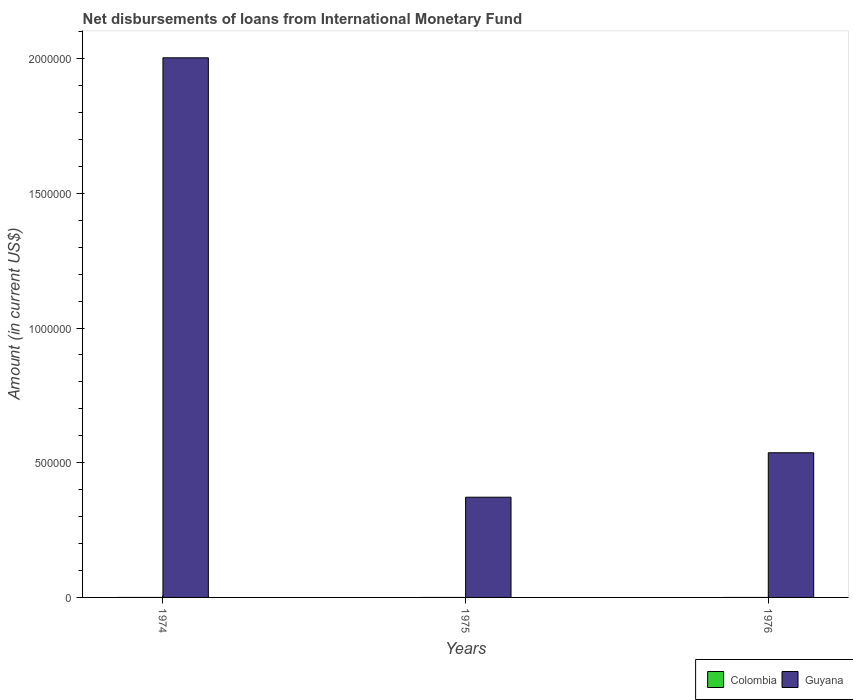How many different coloured bars are there?
Give a very brief answer. 1. How many bars are there on the 1st tick from the left?
Offer a very short reply. 1. What is the label of the 1st group of bars from the left?
Your answer should be very brief. 1974. What is the amount of loans disbursed in Guyana in 1976?
Make the answer very short. 5.37e+05. Across all years, what is the maximum amount of loans disbursed in Guyana?
Offer a terse response. 2.00e+06. Across all years, what is the minimum amount of loans disbursed in Guyana?
Your answer should be compact. 3.72e+05. What is the total amount of loans disbursed in Guyana in the graph?
Your response must be concise. 2.91e+06. What is the difference between the amount of loans disbursed in Guyana in 1974 and that in 1976?
Your response must be concise. 1.47e+06. What is the difference between the amount of loans disbursed in Colombia in 1975 and the amount of loans disbursed in Guyana in 1976?
Offer a very short reply. -5.37e+05. What is the average amount of loans disbursed in Colombia per year?
Provide a succinct answer. 0. In how many years, is the amount of loans disbursed in Guyana greater than 1900000 US$?
Provide a succinct answer. 1. What is the ratio of the amount of loans disbursed in Guyana in 1975 to that in 1976?
Ensure brevity in your answer.  0.69. What is the difference between the highest and the second highest amount of loans disbursed in Guyana?
Offer a very short reply. 1.47e+06. What is the difference between the highest and the lowest amount of loans disbursed in Guyana?
Make the answer very short. 1.63e+06. In how many years, is the amount of loans disbursed in Colombia greater than the average amount of loans disbursed in Colombia taken over all years?
Provide a short and direct response. 0. Is the sum of the amount of loans disbursed in Guyana in 1974 and 1976 greater than the maximum amount of loans disbursed in Colombia across all years?
Offer a very short reply. Yes. How many years are there in the graph?
Give a very brief answer. 3. What is the difference between two consecutive major ticks on the Y-axis?
Your answer should be compact. 5.00e+05. Where does the legend appear in the graph?
Offer a very short reply. Bottom right. How many legend labels are there?
Make the answer very short. 2. What is the title of the graph?
Keep it short and to the point. Net disbursements of loans from International Monetary Fund. What is the label or title of the Y-axis?
Keep it short and to the point. Amount (in current US$). What is the Amount (in current US$) in Guyana in 1974?
Make the answer very short. 2.00e+06. What is the Amount (in current US$) of Colombia in 1975?
Your answer should be compact. 0. What is the Amount (in current US$) of Guyana in 1975?
Ensure brevity in your answer.  3.72e+05. What is the Amount (in current US$) of Guyana in 1976?
Provide a succinct answer. 5.37e+05. Across all years, what is the maximum Amount (in current US$) of Guyana?
Make the answer very short. 2.00e+06. Across all years, what is the minimum Amount (in current US$) of Guyana?
Your answer should be very brief. 3.72e+05. What is the total Amount (in current US$) in Guyana in the graph?
Your answer should be very brief. 2.91e+06. What is the difference between the Amount (in current US$) in Guyana in 1974 and that in 1975?
Provide a succinct answer. 1.63e+06. What is the difference between the Amount (in current US$) of Guyana in 1974 and that in 1976?
Offer a terse response. 1.47e+06. What is the difference between the Amount (in current US$) in Guyana in 1975 and that in 1976?
Offer a very short reply. -1.65e+05. What is the average Amount (in current US$) in Guyana per year?
Offer a very short reply. 9.71e+05. What is the ratio of the Amount (in current US$) in Guyana in 1974 to that in 1975?
Your answer should be compact. 5.38. What is the ratio of the Amount (in current US$) of Guyana in 1974 to that in 1976?
Keep it short and to the point. 3.73. What is the ratio of the Amount (in current US$) in Guyana in 1975 to that in 1976?
Your response must be concise. 0.69. What is the difference between the highest and the second highest Amount (in current US$) in Guyana?
Provide a short and direct response. 1.47e+06. What is the difference between the highest and the lowest Amount (in current US$) in Guyana?
Ensure brevity in your answer.  1.63e+06. 